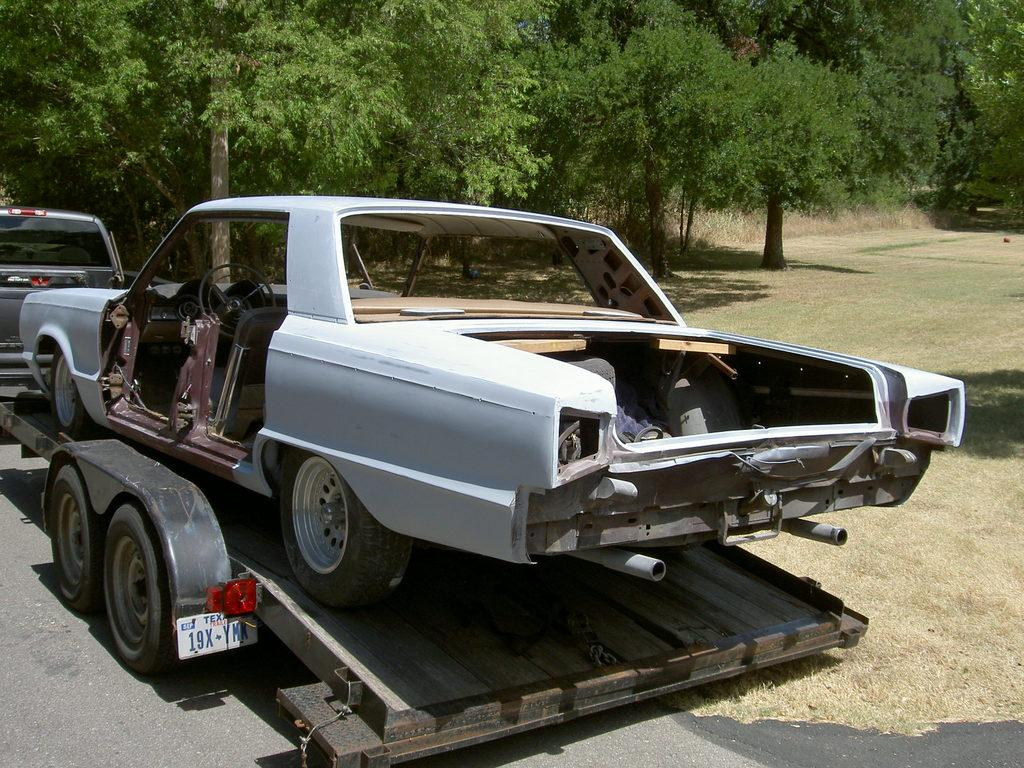What is the main subject of the image? There is a vehicle on the road in the image. What type of vehicle is it? The vehicle has a white-colored car on it. What can be seen in the background of the image? There is ground and trees visible in the background of the image. What is the color of the trees? The trees are green in color. How many kittens are playing on the boat in the image? There is no boat or kittens present in the image. What type of way is depicted in the image? There is no specific way or path shown in the image; it features a vehicle on the road with a white-colored car on it. 